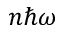<formula> <loc_0><loc_0><loc_500><loc_500>n \hbar { \omega }</formula> 